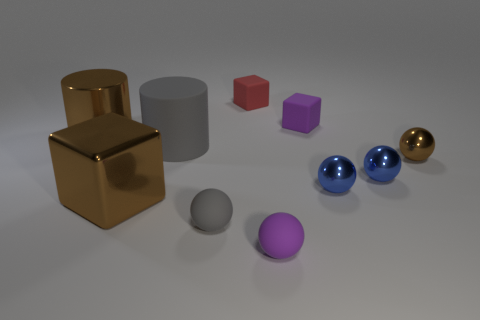What shape is the brown thing that is the same size as the purple rubber ball?
Keep it short and to the point. Sphere. Are there any other things of the same color as the large rubber object?
Provide a succinct answer. Yes. There is a gray cylinder that is made of the same material as the small gray sphere; what size is it?
Offer a very short reply. Large. There is a big rubber thing; is it the same shape as the brown thing that is behind the tiny brown object?
Your answer should be very brief. Yes. What size is the brown cylinder?
Offer a terse response. Large. Are there fewer brown cylinders that are to the right of the purple sphere than large blue things?
Give a very brief answer. No. What number of red rubber things are the same size as the purple sphere?
Give a very brief answer. 1. The small thing that is the same color as the large cube is what shape?
Your response must be concise. Sphere. Is the color of the cube that is to the left of the big matte cylinder the same as the big metallic thing that is left of the large brown metal block?
Offer a terse response. Yes. How many blue objects are left of the brown metallic cube?
Your answer should be very brief. 0. 